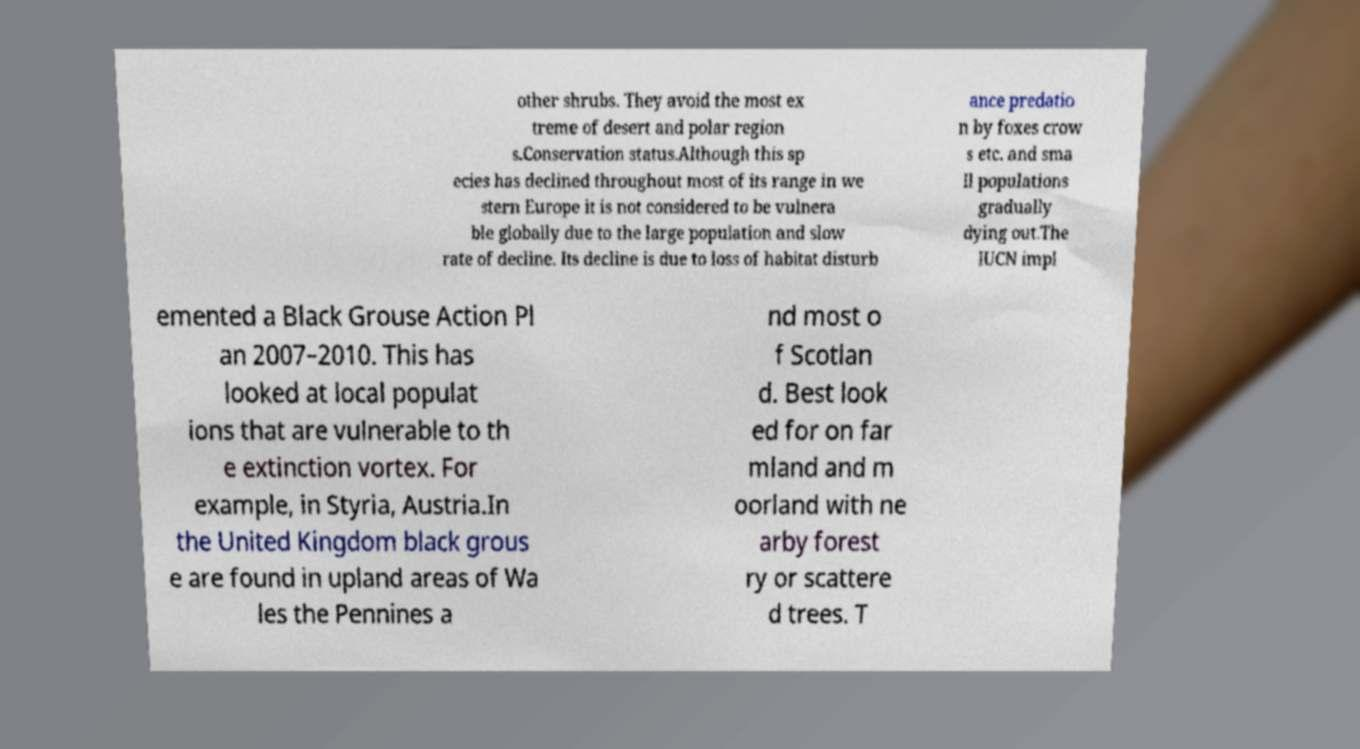Can you accurately transcribe the text from the provided image for me? other shrubs. They avoid the most ex treme of desert and polar region s.Conservation status.Although this sp ecies has declined throughout most of its range in we stern Europe it is not considered to be vulnera ble globally due to the large population and slow rate of decline. Its decline is due to loss of habitat disturb ance predatio n by foxes crow s etc. and sma ll populations gradually dying out.The IUCN impl emented a Black Grouse Action Pl an 2007–2010. This has looked at local populat ions that are vulnerable to th e extinction vortex. For example, in Styria, Austria.In the United Kingdom black grous e are found in upland areas of Wa les the Pennines a nd most o f Scotlan d. Best look ed for on far mland and m oorland with ne arby forest ry or scattere d trees. T 